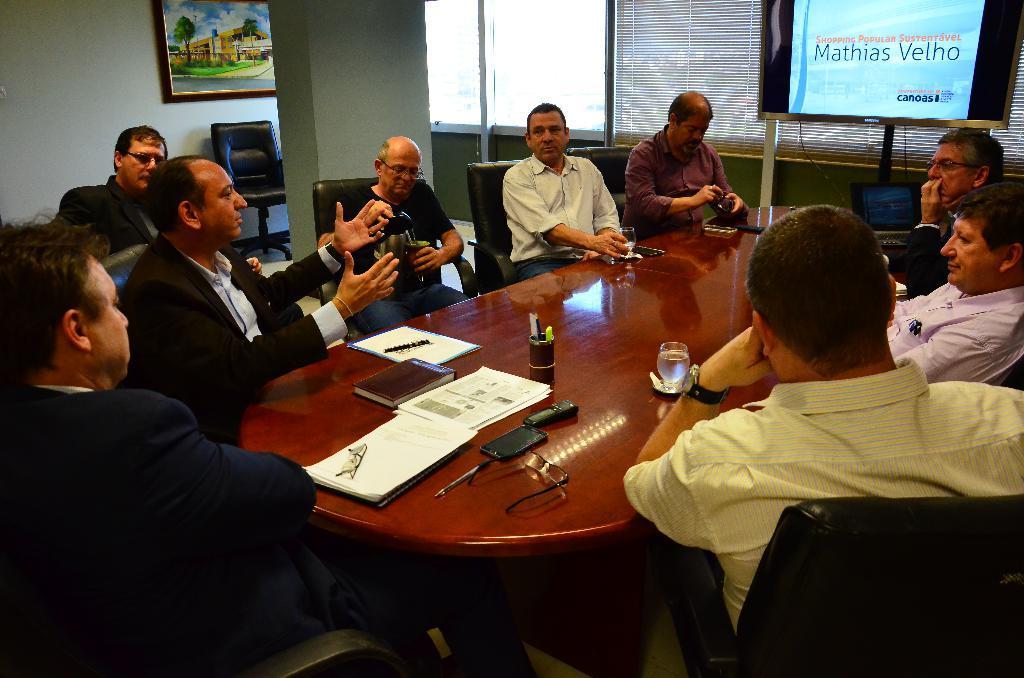Describe this image in one or two sentences. In this image I can see group of people sitting. In front I can see the person is wearing yellow color shirt and I can also see few buildings, papers, books, pens on the table and the table is in brown color, background I can see a frame attached to the wall and the wall is in white color. I can also see a projector screen and few windows. 